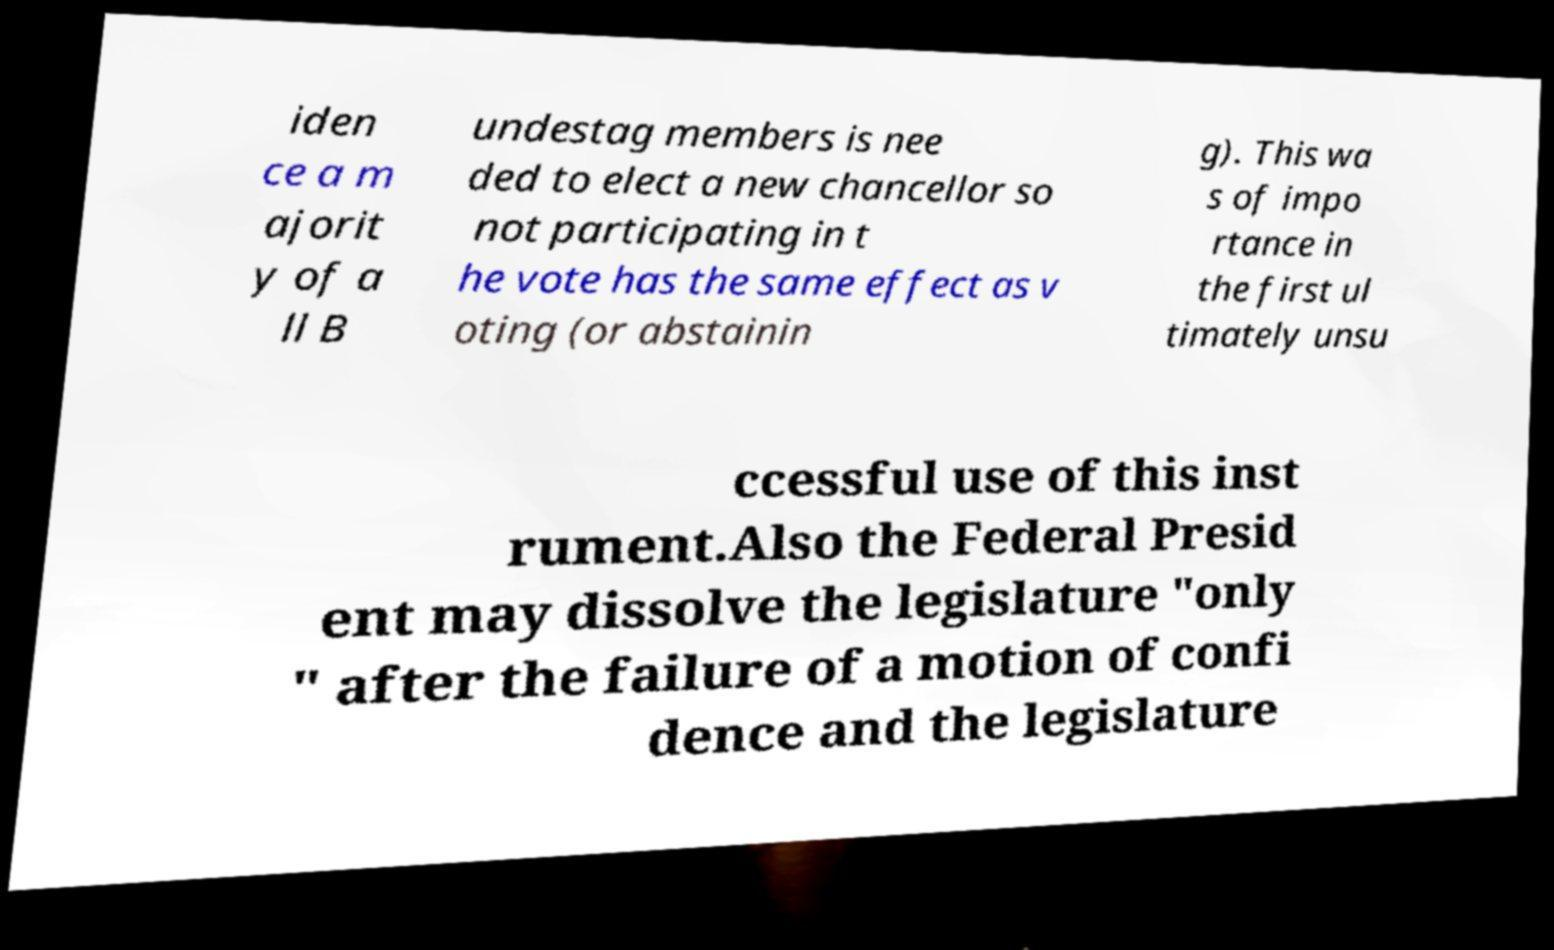Can you read and provide the text displayed in the image?This photo seems to have some interesting text. Can you extract and type it out for me? iden ce a m ajorit y of a ll B undestag members is nee ded to elect a new chancellor so not participating in t he vote has the same effect as v oting (or abstainin g). This wa s of impo rtance in the first ul timately unsu ccessful use of this inst rument.Also the Federal Presid ent may dissolve the legislature "only " after the failure of a motion of confi dence and the legislature 